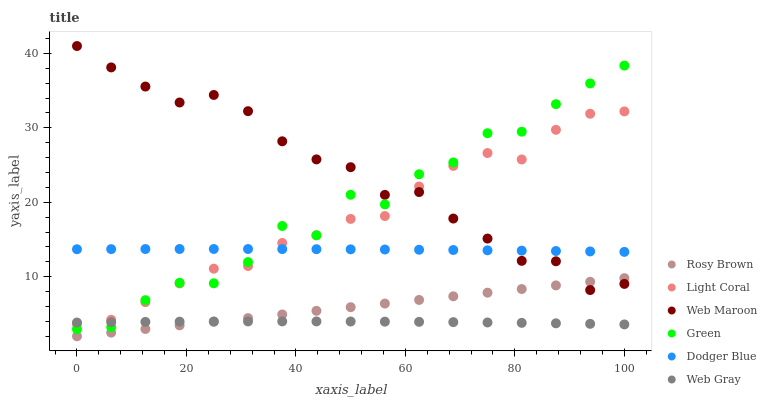Does Web Gray have the minimum area under the curve?
Answer yes or no. Yes. Does Web Maroon have the maximum area under the curve?
Answer yes or no. Yes. Does Rosy Brown have the minimum area under the curve?
Answer yes or no. No. Does Rosy Brown have the maximum area under the curve?
Answer yes or no. No. Is Rosy Brown the smoothest?
Answer yes or no. Yes. Is Green the roughest?
Answer yes or no. Yes. Is Web Maroon the smoothest?
Answer yes or no. No. Is Web Maroon the roughest?
Answer yes or no. No. Does Rosy Brown have the lowest value?
Answer yes or no. Yes. Does Web Maroon have the lowest value?
Answer yes or no. No. Does Web Maroon have the highest value?
Answer yes or no. Yes. Does Rosy Brown have the highest value?
Answer yes or no. No. Is Rosy Brown less than Light Coral?
Answer yes or no. Yes. Is Green greater than Rosy Brown?
Answer yes or no. Yes. Does Web Gray intersect Green?
Answer yes or no. Yes. Is Web Gray less than Green?
Answer yes or no. No. Is Web Gray greater than Green?
Answer yes or no. No. Does Rosy Brown intersect Light Coral?
Answer yes or no. No. 